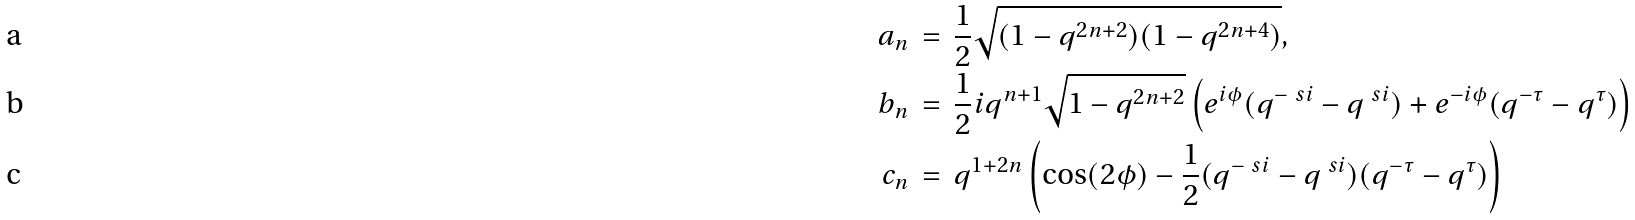Convert formula to latex. <formula><loc_0><loc_0><loc_500><loc_500>a _ { n } \, & = \, \frac { 1 } { 2 } \sqrt { ( 1 - q ^ { 2 n + 2 } ) ( 1 - q ^ { 2 n + 4 } ) } , \\ b _ { n } \, & = \, \frac { 1 } { 2 } i q ^ { n + 1 } \sqrt { 1 - q ^ { 2 n + 2 } } \left ( e ^ { i \phi } ( q ^ { - \ s i } - q ^ { \ s i } ) + e ^ { - i \phi } ( q ^ { - \tau } - q ^ { \tau } ) \right ) \\ c _ { n } \, & = \, q ^ { 1 + 2 n } \left ( \cos ( 2 \phi ) - \frac { 1 } { 2 } ( q ^ { - \ s i } - q ^ { \ s i } ) ( q ^ { - \tau } - q ^ { \tau } ) \right )</formula> 